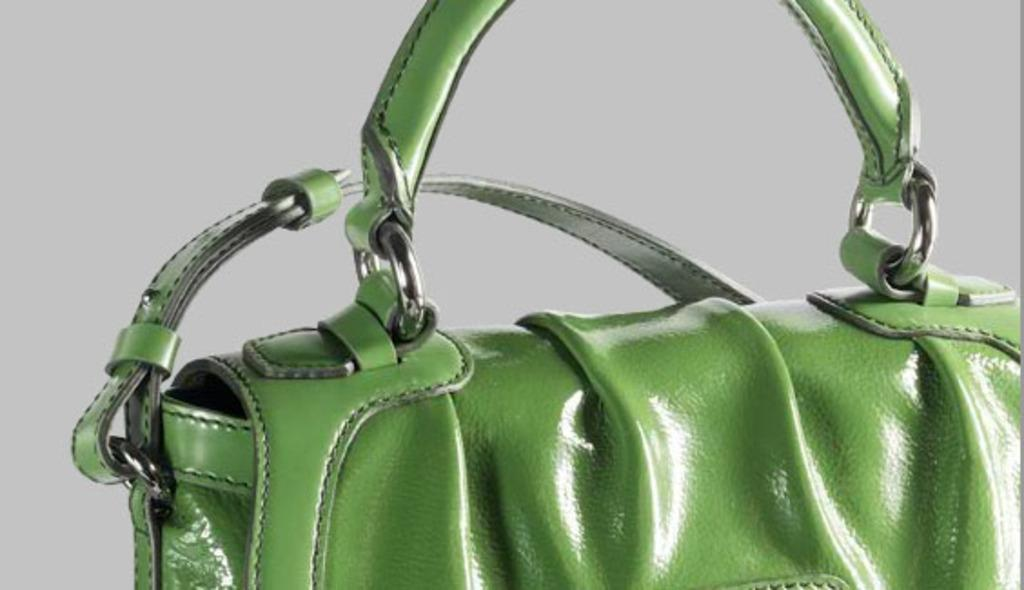What is the color of the handbag in the image? The handbag is green in color. What type of drug is the handbag carrying in the image? There is no indication of any drug in the image; it is a handbag that is green in color. 